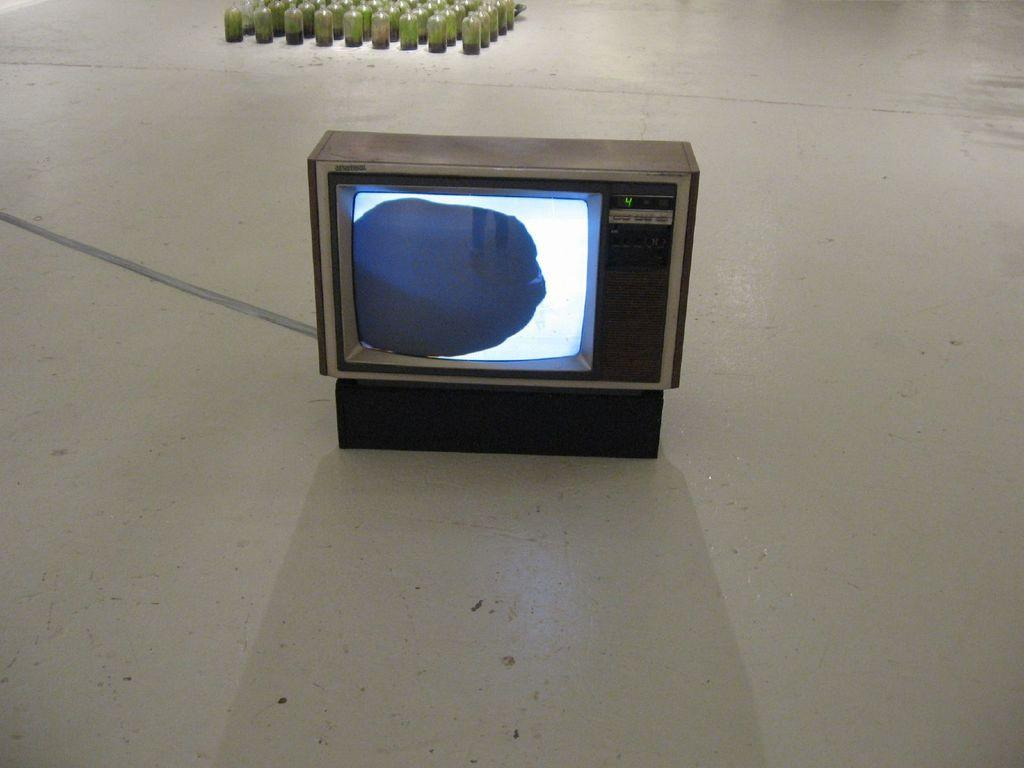<image>
Offer a succinct explanation of the picture presented. a little tv with the number 4 on it 